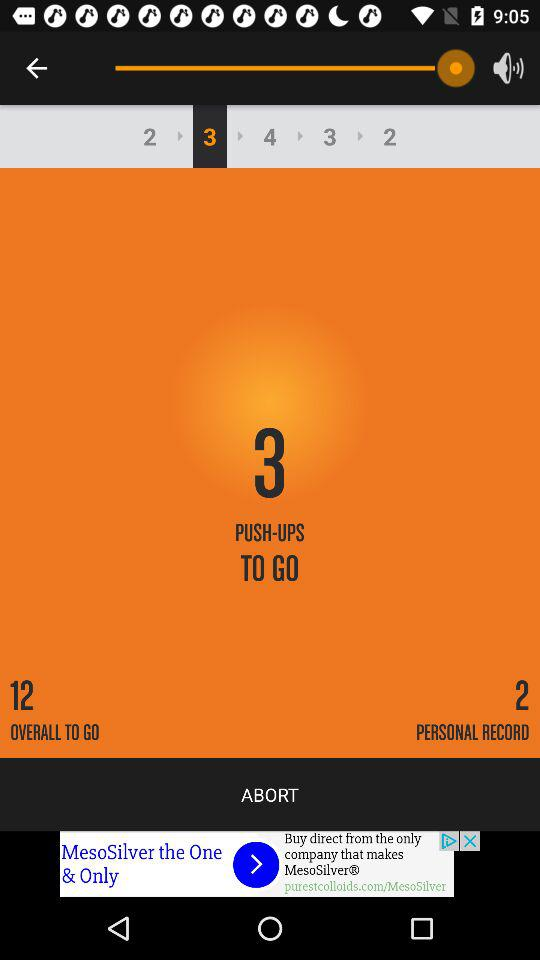What's the sequence to cover the push-ups set? The sequence to cover the push-ups set is 2-3-4-3-2. 